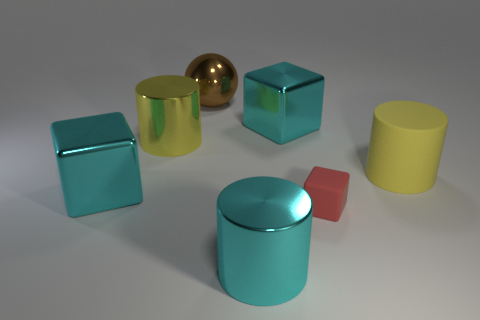What materials do the objects in the image seem to be made of? The objects exhibit various shiny surfaces suggesting they may be composed of materials like glossy plastic, glass, or even metals. For instance, the golden sphere and a couple of the cubes have a reflective surface that is typical of a metallic finish. 